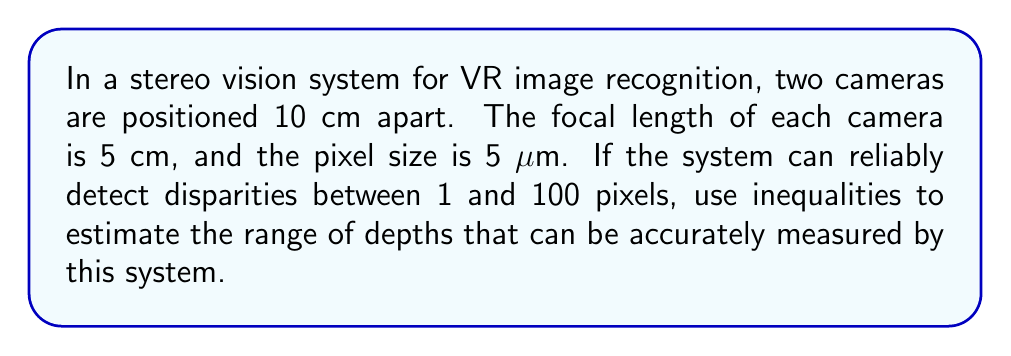Solve this math problem. Let's approach this step-by-step:

1) The depth (Z) in a stereo vision system is related to the disparity (d) by the formula:

   $$Z = \frac{fB}{d}$$

   where f is the focal length and B is the baseline (distance between cameras).

2) We're given:
   - B = 10 cm
   - f = 5 cm
   - Pixel size = 5 μm = 0.0005 cm
   - Disparity range: 1 to 100 pixels

3) Convert disparity from pixels to cm:
   - Minimum disparity: $d_{min} = 1 * 0.0005 = 0.0005$ cm
   - Maximum disparity: $d_{max} = 100 * 0.0005 = 0.05$ cm

4) Set up the inequality for the depth range:

   $$\frac{fB}{d_{max}} \leq Z \leq \frac{fB}{d_{min}}$$

5) Substitute the values:

   $$\frac{5 * 10}{0.05} \leq Z \leq \frac{5 * 10}{0.0005}$$

6) Simplify:

   $$1000 \leq Z \leq 100000$$

7) Therefore, the depth range is from 1000 cm (10 m) to 100000 cm (1000 m).
Answer: $10 \text{ m} \leq Z \leq 1000 \text{ m}$ 